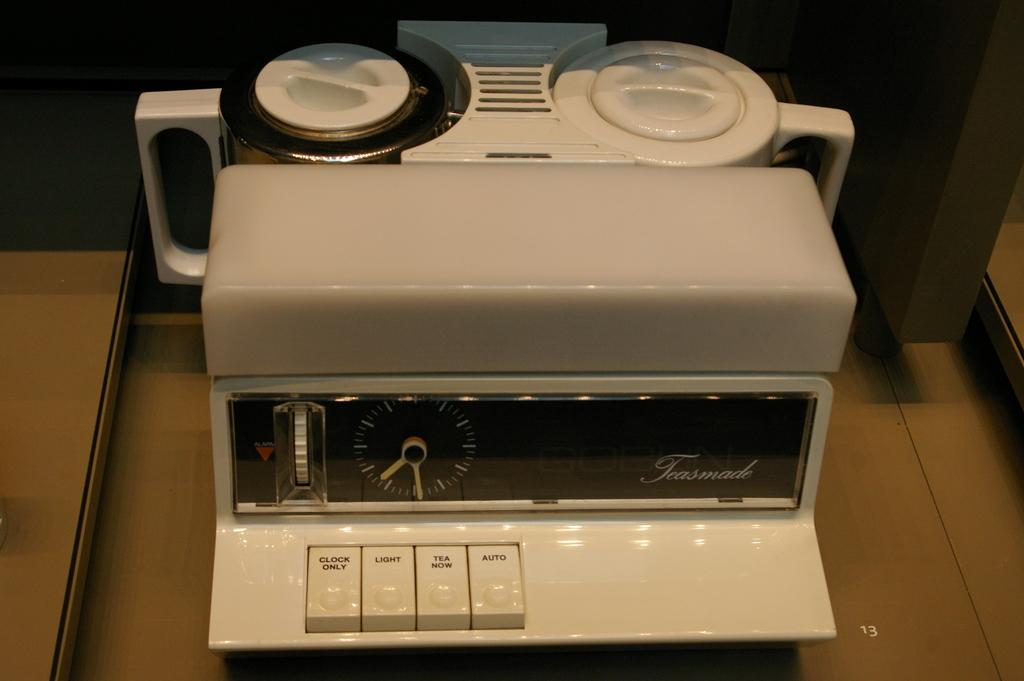<image>
Write a terse but informative summary of the picture. a machine with a button that says tea now 